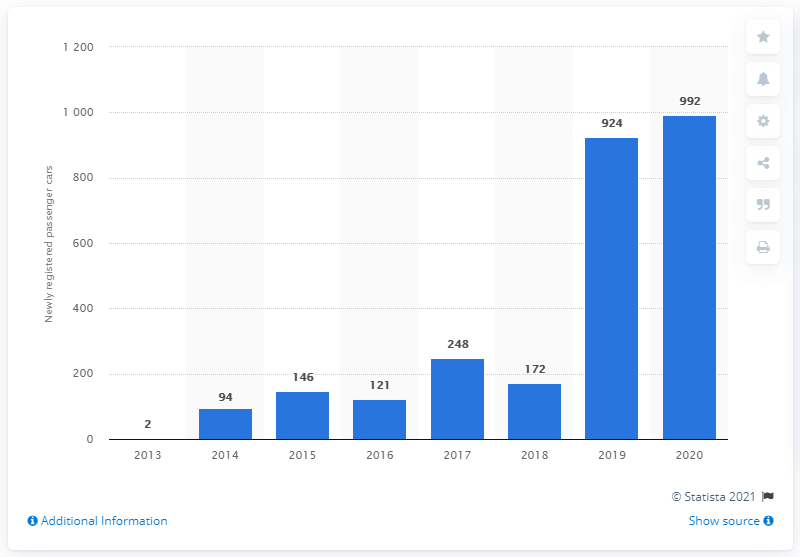Point out several critical features in this image. In 2020, there were 992 new Tesla passenger car registrations. 